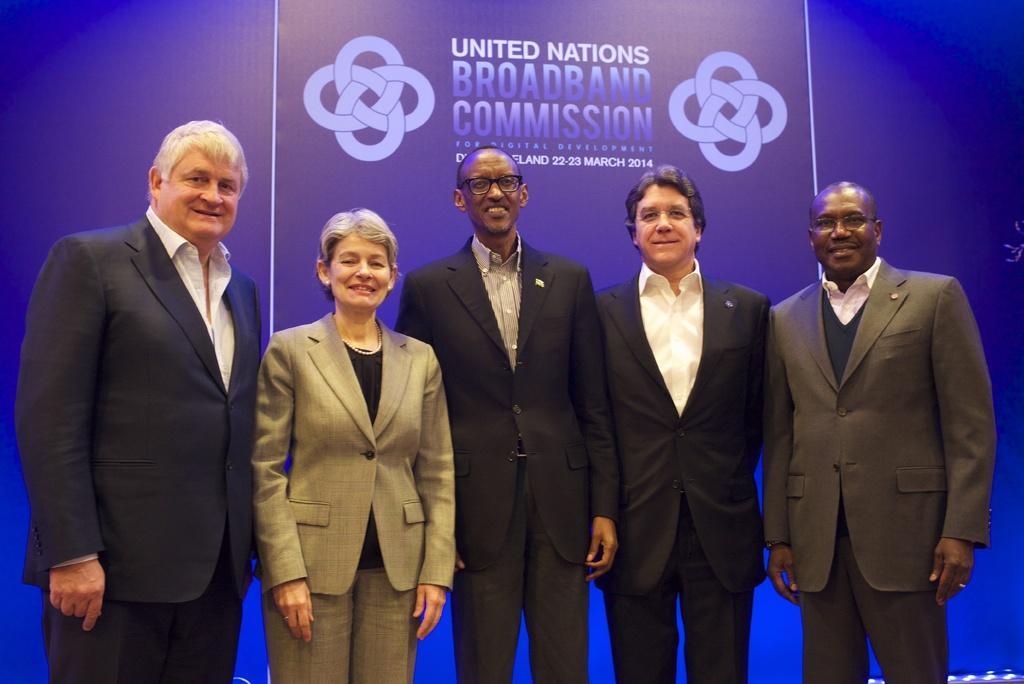Describe this image in one or two sentences. In the picture I can see few persons wearing suits are standing and there is a banner behind them which has something written on it. 